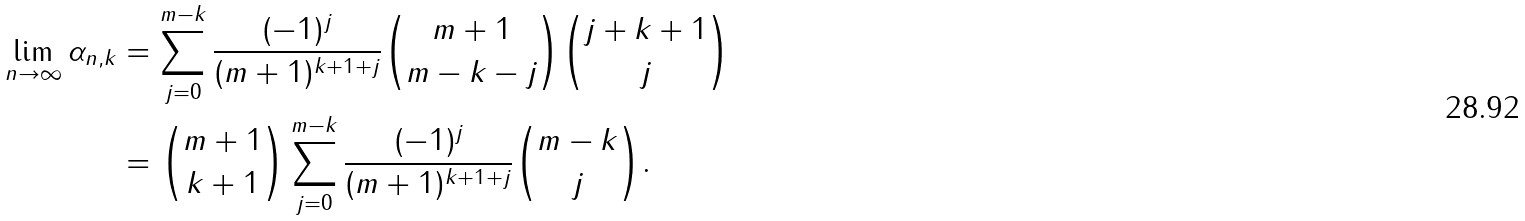<formula> <loc_0><loc_0><loc_500><loc_500>\lim _ { n \to \infty } \alpha _ { n , k } & = \sum _ { j = 0 } ^ { m - k } \frac { ( - 1 ) ^ { j } } { ( m + 1 ) ^ { k + 1 + j } } { m + 1 \choose m - k - j } { j + k + 1 \choose j } \\ & = { m + 1 \choose k + 1 } \sum _ { j = 0 } ^ { m - k } \frac { ( - 1 ) ^ { j } } { ( m + 1 ) ^ { k + 1 + j } } { m - k \choose j } .</formula> 